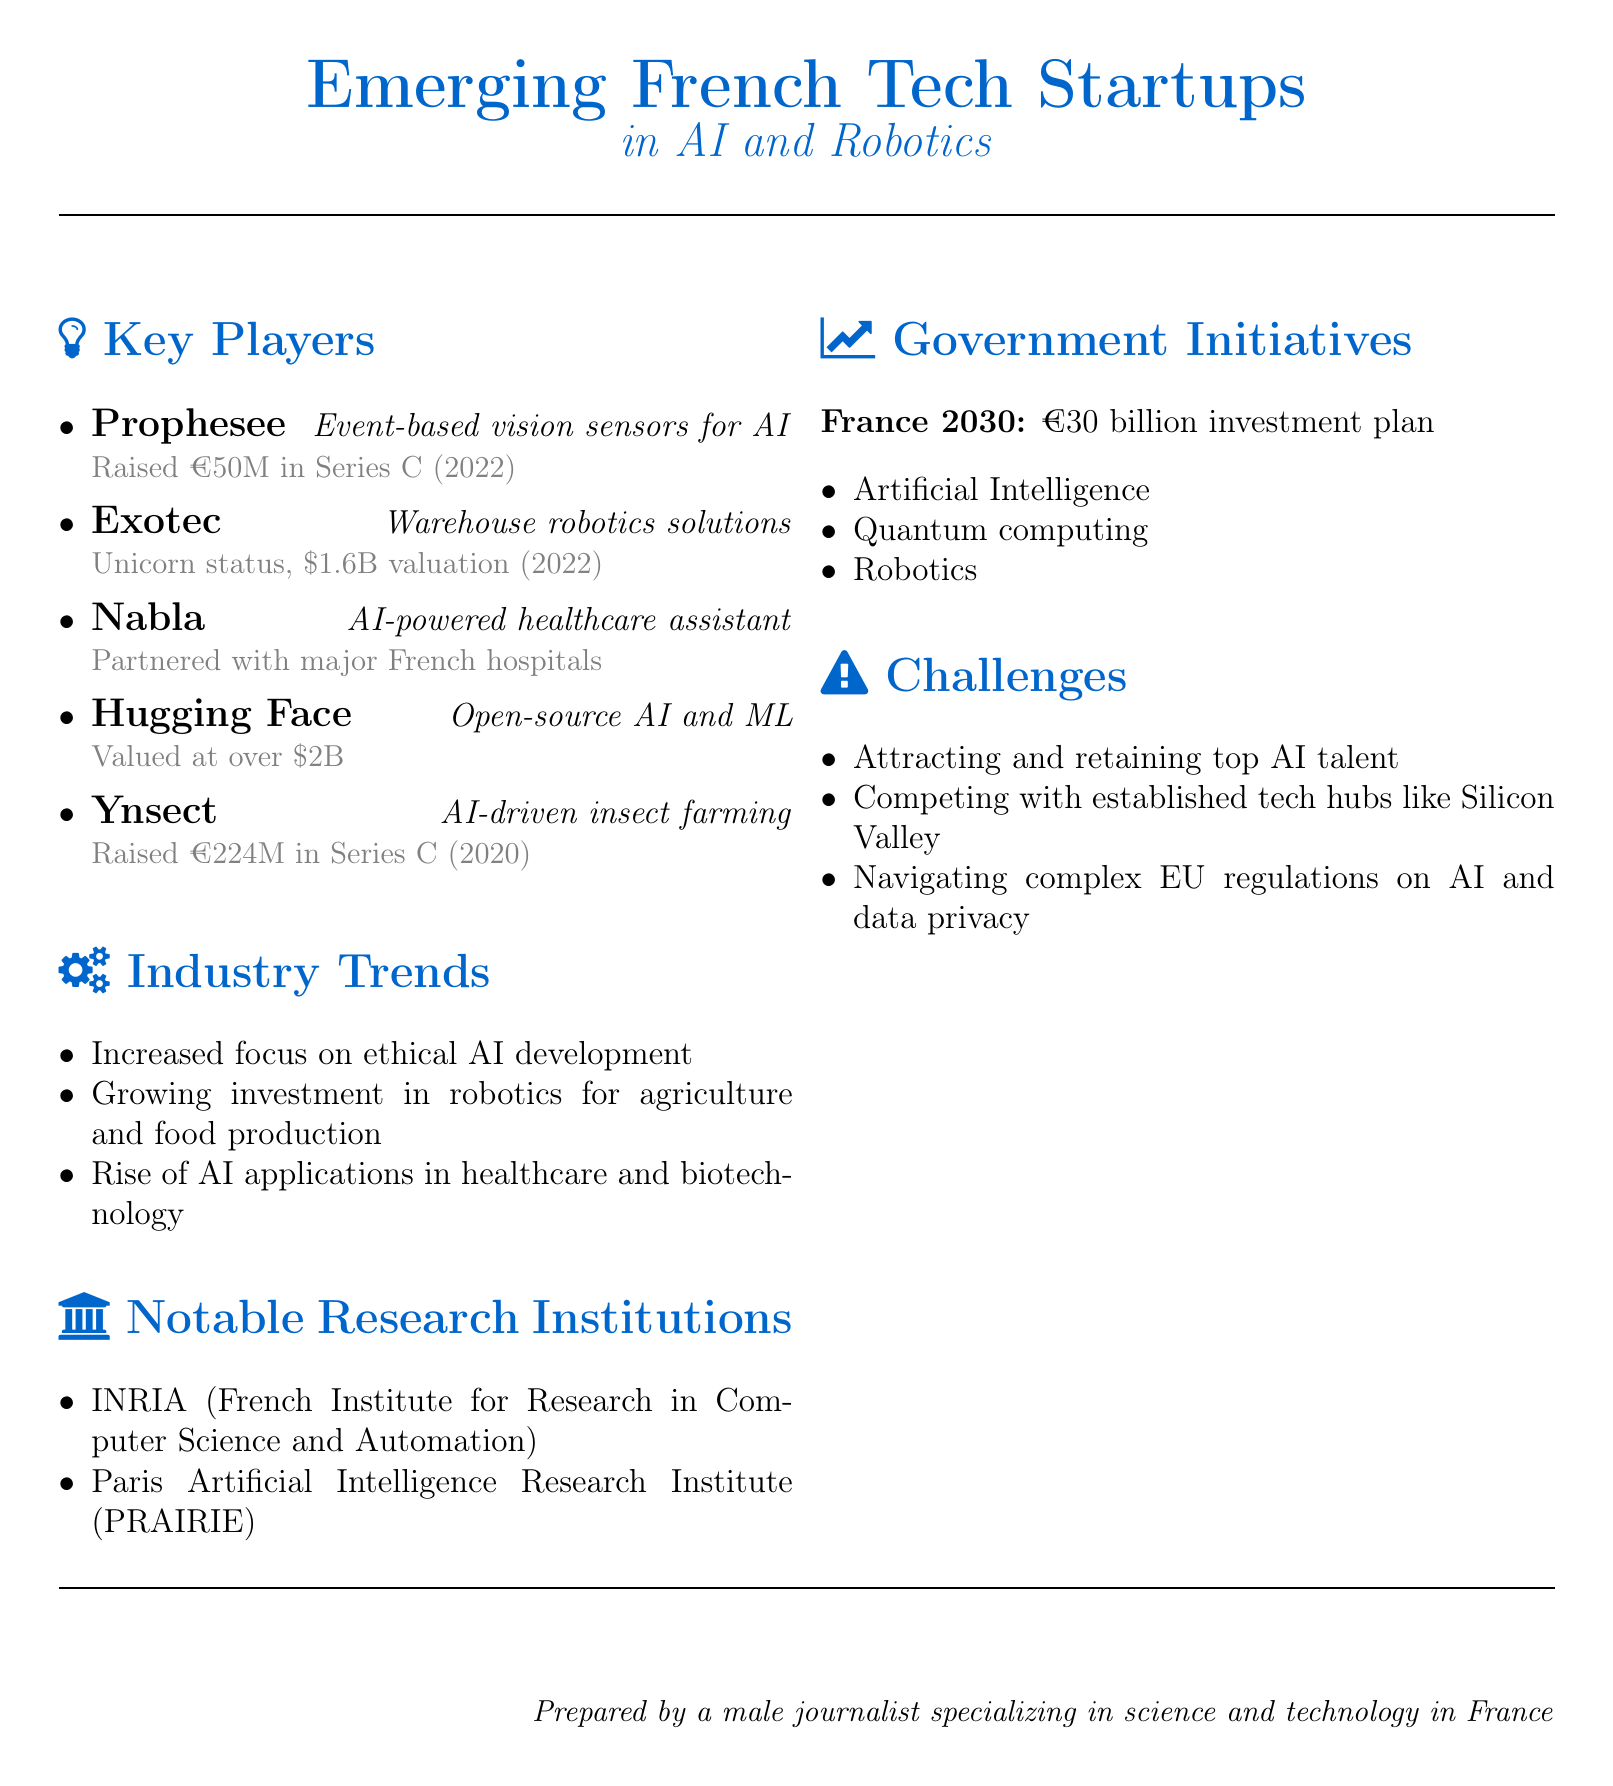What is the valuation of Exotec? The valuation of Exotec is mentioned as $1.6 billion achieved in 2022.
Answer: $1.6 billion Which company focuses on AI-driven insect farming? The company focusing on AI-driven insect farming is Ynsect, as indicated in the document.
Answer: Ynsect How much funding did Prophesee raise in Series C? The document states that Prophesee raised €50 million in Series C funding in 2022.
Answer: €50 million What is one trend in the industry according to the document? The document lists several trends, one of which is the increased focus on ethical AI development.
Answer: Increased focus on ethical AI development What is the budget for the France 2030 initiative? The France 2030 initiative has a budget of €30 billion as stated in the document.
Answer: €30 billion Which notable research institution is associated with computer science in France? The document mentions INRIA (French Institute for Research in Computer Science and Automation) as a notable research institution.
Answer: INRIA What challenge is highlighted regarding the tech talent? The document indicates that attracting and retaining top AI talent is a significant challenge.
Answer: Attracting and retaining top AI talent Which company is valued at over $2 billion? According to the document, Hugging Face is valued at over $2 billion after a recent funding round.
Answer: Hugging Face What year did Ynsect raise its Series C funding? The document mentions that Ynsect raised its Series C funding in 2020.
Answer: 2020 